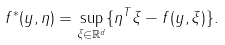<formula> <loc_0><loc_0><loc_500><loc_500>f ^ { * } ( y , \eta ) = \sup _ { \xi \in \mathbb { R } ^ { d } } \{ \eta ^ { T } \xi - f ( y , \xi ) \} .</formula> 